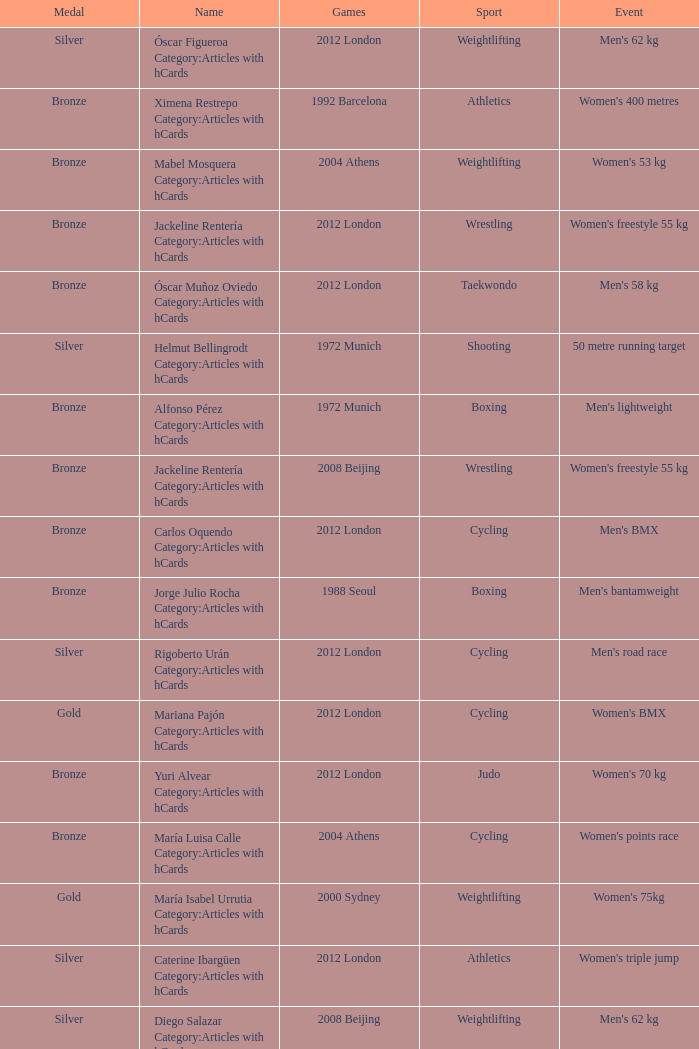Which sport resulted in a gold medal in the 2000 Sydney games? Weightlifting. 